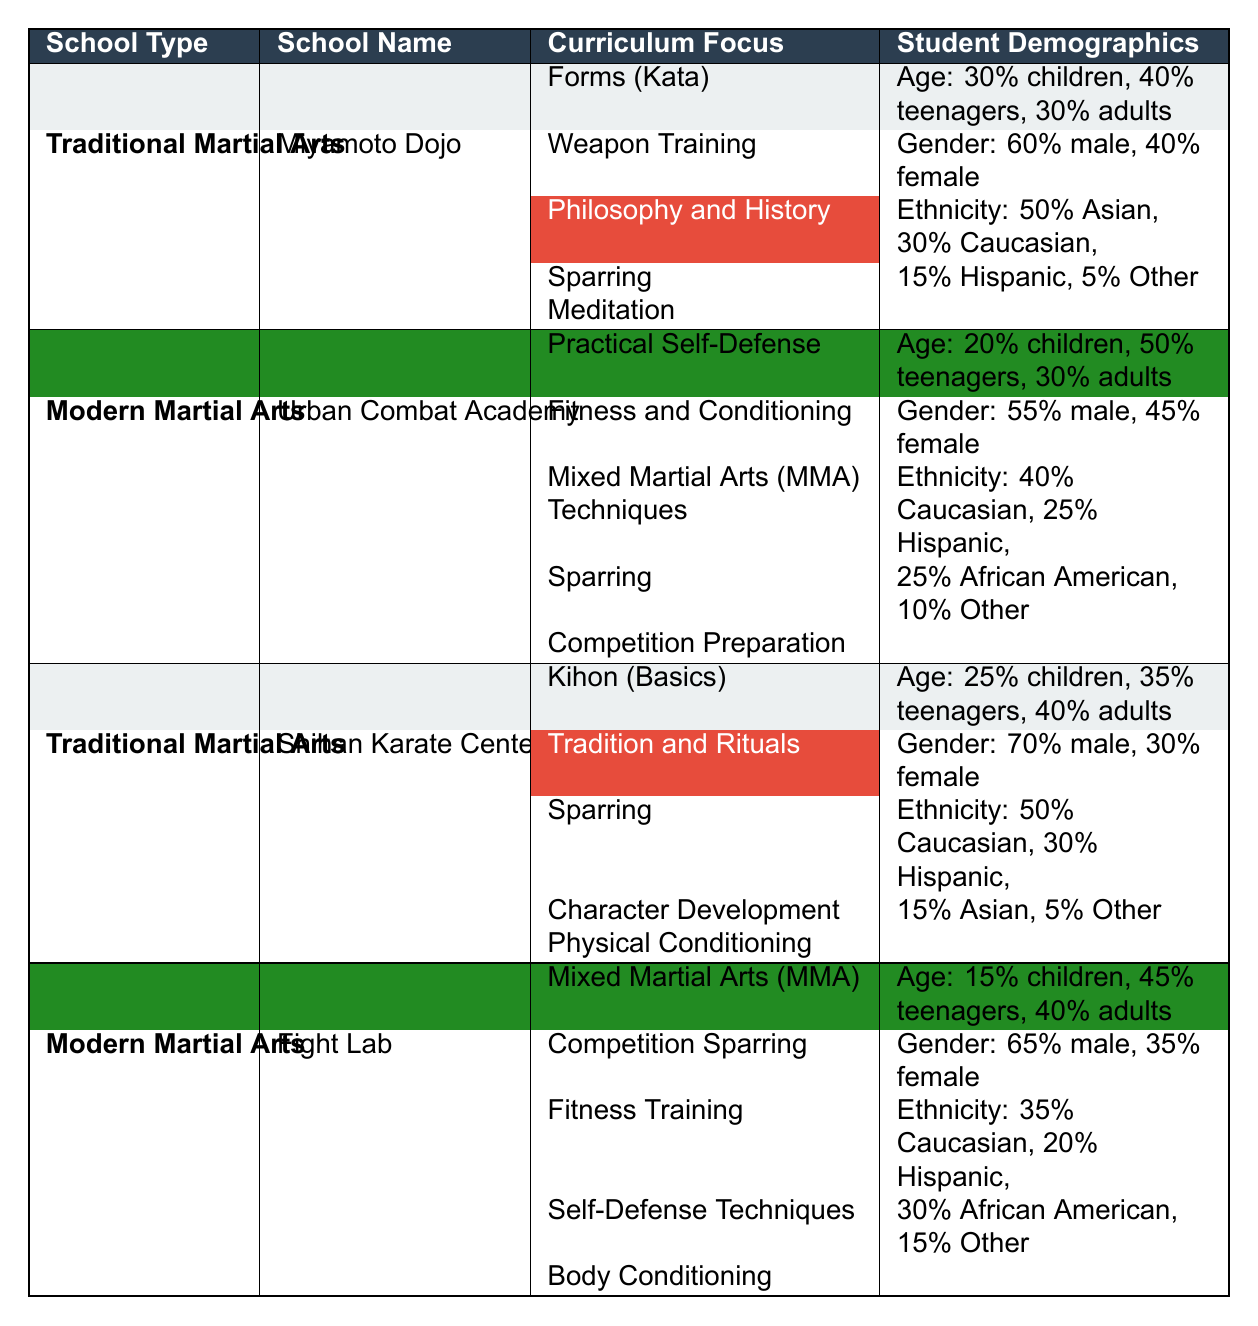What is the curriculum focus of Miyamoto Dojo? The curriculum focus includes Forms (Kata), Weapon Training, Philosophy and History, Sparring, and Meditation, all of which can be found in the table under Miyamoto Dojo.
Answer: Forms, Weapon Training, Philosophy and History, Sparring, Meditation What percentage of students are teenagers at Urban Combat Academy? According to the table, Urban Combat Academy has 50% teenagers as part of their student demographics. This is directly stated in the table.
Answer: 50% Which school has the highest percentage of male students? From the table, Shihan Karate Center has 70% male students, which is higher than the other schools listed.
Answer: Shihan Karate Center What is the average percentage of children across all schools? The percentage of children in each school is as follows: Miyamoto Dojo (30%), Urban Combat Academy (20%), Shihan Karate Center (25%), and Fight Lab (15%). Adding these percentages gives a total of 90%. Dividing by 4 (the number of schools) gives an average of 22.5%.
Answer: 22.5% Is there a school that focuses on competition preparation? Yes, Urban Combat Academy includes competition preparation as part of its curriculum focus. This can be confirmed by looking at the curriculum listed for that school.
Answer: Yes How does the ethnic diversity of Fight Lab compare to Urban Combat Academy? Fight Lab has 35% Caucasian, 20% Hispanic, 30% African American, and 15% Other. Urban Combat Academy has 40% Caucasian, 25% Hispanic, and 25% African American, with 10% Other. Comparing them shows that Fight Lab has a higher percentage of African American students while Urban Combat Academy has a higher percentage of Caucasian students.
Answer: Fight Lab has more African American and Urban Combat Academy has more Caucasian students What is the ratio of male to female students in Shihan Karate Center? The gender ratio in Shihan Karate Center is 70% male to 30% female. To express this as a ratio, it simplifies to 7:3. This can be determined by looking at the gender demographic data in the table.
Answer: 7:3 What is the total percentage of students that are adults across all schools? The percentage of adults is as follows: Miyamoto Dojo (30%), Urban Combat Academy (30%), Shihan Karate Center (40%), and Fight Lab (40%). Adding these percentages gives a total of 140%.
Answer: 140% Which school has a curriculum that emphasizes character development? Shihan Karate Center emphasizes character development as part of its curriculum focus. This is specifically listed in the table for that school.
Answer: Shihan Karate Center What is the percentage of Hispanic students at Miyamoto Dojo compared to Shihan Karate Center? Miyamoto Dojo has 15% Hispanic students, while Shihan Karate Center has 30% Hispanic students. Therefore, Shihan Karate Center has a higher percentage of Hispanic students.
Answer: Shihan Karate Center has more Hispanic students What curriculum focus is unique to Modern Martial Arts schools compared to Traditional Martial Arts schools? Modern Martial Arts schools have a curriculum focus on Practical Self-Defense and Mixed Martial Arts (MMA) Techniques, which are not listed in the curriculum focuses of Traditional Martial Arts schools. This can be deduced from comparing the curriculum sections of the schools.
Answer: Practical Self-Defense and Mixed Martial Arts (MMA) Techniques 